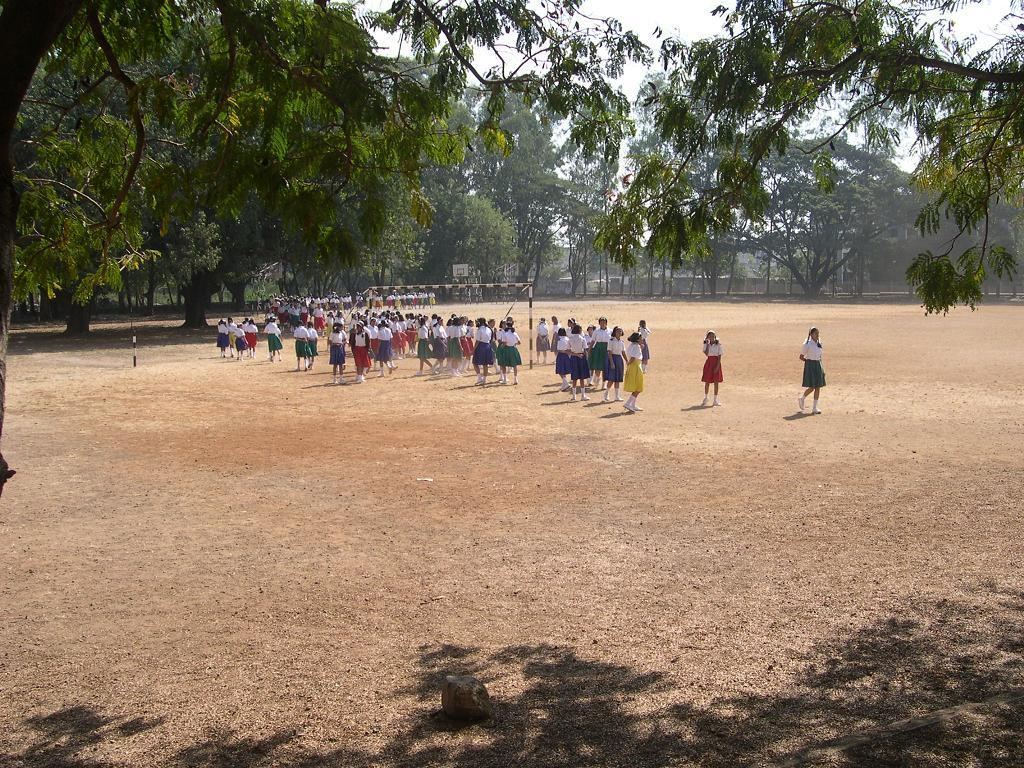How many people are in the image? There is a group of people in the image. Where are the people located in the image? The people are on a path. What can be seen in the background of the image? There are trees in the background of the image. What type of skirt is the bee wearing in the image? There is no bee or skirt present in the image. Can you describe the stranger in the image? There is no stranger mentioned in the image; it features a group of people. 